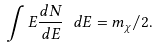<formula> <loc_0><loc_0><loc_500><loc_500>\int E \frac { d N } { d E } \ d E = m _ { \chi } / 2 .</formula> 